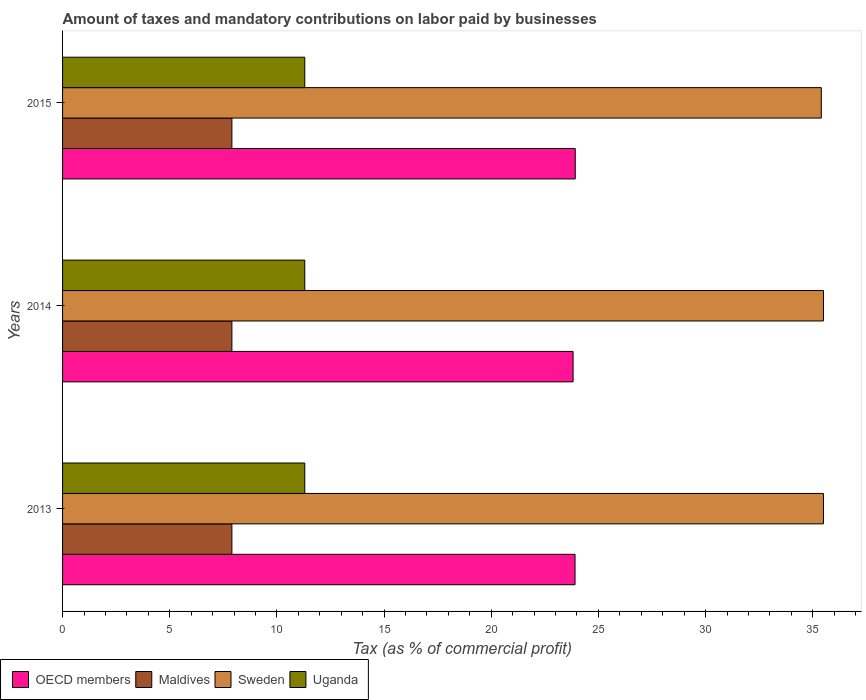How many different coloured bars are there?
Offer a very short reply. 4. How many groups of bars are there?
Keep it short and to the point. 3. How many bars are there on the 3rd tick from the bottom?
Ensure brevity in your answer.  4. What is the label of the 2nd group of bars from the top?
Provide a short and direct response. 2014. In how many cases, is the number of bars for a given year not equal to the number of legend labels?
Give a very brief answer. 0. What is the percentage of taxes paid by businesses in Maldives in 2013?
Keep it short and to the point. 7.9. Across all years, what is the maximum percentage of taxes paid by businesses in Sweden?
Ensure brevity in your answer.  35.5. Across all years, what is the minimum percentage of taxes paid by businesses in OECD members?
Provide a short and direct response. 23.82. In which year was the percentage of taxes paid by businesses in OECD members maximum?
Your answer should be compact. 2015. In which year was the percentage of taxes paid by businesses in OECD members minimum?
Make the answer very short. 2014. What is the total percentage of taxes paid by businesses in Maldives in the graph?
Provide a succinct answer. 23.7. What is the difference between the percentage of taxes paid by businesses in OECD members in 2014 and the percentage of taxes paid by businesses in Sweden in 2015?
Your response must be concise. -11.58. What is the average percentage of taxes paid by businesses in OECD members per year?
Make the answer very short. 23.88. In the year 2014, what is the difference between the percentage of taxes paid by businesses in Uganda and percentage of taxes paid by businesses in OECD members?
Ensure brevity in your answer.  -12.52. What is the ratio of the percentage of taxes paid by businesses in OECD members in 2013 to that in 2014?
Give a very brief answer. 1. Is the difference between the percentage of taxes paid by businesses in Uganda in 2014 and 2015 greater than the difference between the percentage of taxes paid by businesses in OECD members in 2014 and 2015?
Provide a short and direct response. Yes. What is the difference between the highest and the second highest percentage of taxes paid by businesses in Uganda?
Provide a succinct answer. 0. What is the difference between the highest and the lowest percentage of taxes paid by businesses in Sweden?
Keep it short and to the point. 0.1. Is it the case that in every year, the sum of the percentage of taxes paid by businesses in Uganda and percentage of taxes paid by businesses in Maldives is greater than the percentage of taxes paid by businesses in Sweden?
Your response must be concise. No. How many bars are there?
Keep it short and to the point. 12. Are all the bars in the graph horizontal?
Ensure brevity in your answer.  Yes. How many years are there in the graph?
Provide a succinct answer. 3. What is the difference between two consecutive major ticks on the X-axis?
Provide a succinct answer. 5. Are the values on the major ticks of X-axis written in scientific E-notation?
Provide a short and direct response. No. Does the graph contain any zero values?
Provide a short and direct response. No. Does the graph contain grids?
Keep it short and to the point. No. How many legend labels are there?
Provide a short and direct response. 4. What is the title of the graph?
Ensure brevity in your answer.  Amount of taxes and mandatory contributions on labor paid by businesses. Does "Congo (Democratic)" appear as one of the legend labels in the graph?
Keep it short and to the point. No. What is the label or title of the X-axis?
Offer a terse response. Tax (as % of commercial profit). What is the label or title of the Y-axis?
Your response must be concise. Years. What is the Tax (as % of commercial profit) of OECD members in 2013?
Offer a terse response. 23.91. What is the Tax (as % of commercial profit) of Sweden in 2013?
Your response must be concise. 35.5. What is the Tax (as % of commercial profit) in Uganda in 2013?
Provide a short and direct response. 11.3. What is the Tax (as % of commercial profit) in OECD members in 2014?
Ensure brevity in your answer.  23.82. What is the Tax (as % of commercial profit) in Sweden in 2014?
Give a very brief answer. 35.5. What is the Tax (as % of commercial profit) in Uganda in 2014?
Provide a short and direct response. 11.3. What is the Tax (as % of commercial profit) of OECD members in 2015?
Keep it short and to the point. 23.92. What is the Tax (as % of commercial profit) in Sweden in 2015?
Ensure brevity in your answer.  35.4. What is the Tax (as % of commercial profit) in Uganda in 2015?
Offer a very short reply. 11.3. Across all years, what is the maximum Tax (as % of commercial profit) in OECD members?
Give a very brief answer. 23.92. Across all years, what is the maximum Tax (as % of commercial profit) of Maldives?
Provide a short and direct response. 7.9. Across all years, what is the maximum Tax (as % of commercial profit) in Sweden?
Keep it short and to the point. 35.5. Across all years, what is the maximum Tax (as % of commercial profit) in Uganda?
Provide a succinct answer. 11.3. Across all years, what is the minimum Tax (as % of commercial profit) of OECD members?
Make the answer very short. 23.82. Across all years, what is the minimum Tax (as % of commercial profit) of Sweden?
Offer a terse response. 35.4. What is the total Tax (as % of commercial profit) of OECD members in the graph?
Your answer should be very brief. 71.65. What is the total Tax (as % of commercial profit) in Maldives in the graph?
Provide a succinct answer. 23.7. What is the total Tax (as % of commercial profit) of Sweden in the graph?
Provide a short and direct response. 106.4. What is the total Tax (as % of commercial profit) in Uganda in the graph?
Ensure brevity in your answer.  33.9. What is the difference between the Tax (as % of commercial profit) of OECD members in 2013 and that in 2014?
Ensure brevity in your answer.  0.09. What is the difference between the Tax (as % of commercial profit) in Maldives in 2013 and that in 2014?
Offer a very short reply. 0. What is the difference between the Tax (as % of commercial profit) in Sweden in 2013 and that in 2014?
Offer a terse response. 0. What is the difference between the Tax (as % of commercial profit) of OECD members in 2013 and that in 2015?
Offer a very short reply. -0.01. What is the difference between the Tax (as % of commercial profit) of Uganda in 2013 and that in 2015?
Make the answer very short. 0. What is the difference between the Tax (as % of commercial profit) in Maldives in 2014 and that in 2015?
Offer a terse response. 0. What is the difference between the Tax (as % of commercial profit) in Sweden in 2014 and that in 2015?
Provide a succinct answer. 0.1. What is the difference between the Tax (as % of commercial profit) of Uganda in 2014 and that in 2015?
Offer a terse response. 0. What is the difference between the Tax (as % of commercial profit) in OECD members in 2013 and the Tax (as % of commercial profit) in Maldives in 2014?
Provide a succinct answer. 16.01. What is the difference between the Tax (as % of commercial profit) in OECD members in 2013 and the Tax (as % of commercial profit) in Sweden in 2014?
Your answer should be very brief. -11.59. What is the difference between the Tax (as % of commercial profit) of OECD members in 2013 and the Tax (as % of commercial profit) of Uganda in 2014?
Give a very brief answer. 12.61. What is the difference between the Tax (as % of commercial profit) in Maldives in 2013 and the Tax (as % of commercial profit) in Sweden in 2014?
Offer a very short reply. -27.6. What is the difference between the Tax (as % of commercial profit) of Sweden in 2013 and the Tax (as % of commercial profit) of Uganda in 2014?
Provide a short and direct response. 24.2. What is the difference between the Tax (as % of commercial profit) in OECD members in 2013 and the Tax (as % of commercial profit) in Maldives in 2015?
Keep it short and to the point. 16.01. What is the difference between the Tax (as % of commercial profit) in OECD members in 2013 and the Tax (as % of commercial profit) in Sweden in 2015?
Your answer should be very brief. -11.49. What is the difference between the Tax (as % of commercial profit) of OECD members in 2013 and the Tax (as % of commercial profit) of Uganda in 2015?
Your answer should be compact. 12.61. What is the difference between the Tax (as % of commercial profit) in Maldives in 2013 and the Tax (as % of commercial profit) in Sweden in 2015?
Ensure brevity in your answer.  -27.5. What is the difference between the Tax (as % of commercial profit) in Maldives in 2013 and the Tax (as % of commercial profit) in Uganda in 2015?
Give a very brief answer. -3.4. What is the difference between the Tax (as % of commercial profit) of Sweden in 2013 and the Tax (as % of commercial profit) of Uganda in 2015?
Give a very brief answer. 24.2. What is the difference between the Tax (as % of commercial profit) in OECD members in 2014 and the Tax (as % of commercial profit) in Maldives in 2015?
Offer a very short reply. 15.92. What is the difference between the Tax (as % of commercial profit) of OECD members in 2014 and the Tax (as % of commercial profit) of Sweden in 2015?
Make the answer very short. -11.58. What is the difference between the Tax (as % of commercial profit) in OECD members in 2014 and the Tax (as % of commercial profit) in Uganda in 2015?
Offer a terse response. 12.52. What is the difference between the Tax (as % of commercial profit) in Maldives in 2014 and the Tax (as % of commercial profit) in Sweden in 2015?
Your response must be concise. -27.5. What is the difference between the Tax (as % of commercial profit) in Maldives in 2014 and the Tax (as % of commercial profit) in Uganda in 2015?
Offer a very short reply. -3.4. What is the difference between the Tax (as % of commercial profit) in Sweden in 2014 and the Tax (as % of commercial profit) in Uganda in 2015?
Your answer should be very brief. 24.2. What is the average Tax (as % of commercial profit) in OECD members per year?
Ensure brevity in your answer.  23.88. What is the average Tax (as % of commercial profit) in Sweden per year?
Your answer should be compact. 35.47. In the year 2013, what is the difference between the Tax (as % of commercial profit) of OECD members and Tax (as % of commercial profit) of Maldives?
Your response must be concise. 16.01. In the year 2013, what is the difference between the Tax (as % of commercial profit) of OECD members and Tax (as % of commercial profit) of Sweden?
Your answer should be compact. -11.59. In the year 2013, what is the difference between the Tax (as % of commercial profit) of OECD members and Tax (as % of commercial profit) of Uganda?
Give a very brief answer. 12.61. In the year 2013, what is the difference between the Tax (as % of commercial profit) of Maldives and Tax (as % of commercial profit) of Sweden?
Provide a succinct answer. -27.6. In the year 2013, what is the difference between the Tax (as % of commercial profit) in Maldives and Tax (as % of commercial profit) in Uganda?
Make the answer very short. -3.4. In the year 2013, what is the difference between the Tax (as % of commercial profit) in Sweden and Tax (as % of commercial profit) in Uganda?
Keep it short and to the point. 24.2. In the year 2014, what is the difference between the Tax (as % of commercial profit) in OECD members and Tax (as % of commercial profit) in Maldives?
Give a very brief answer. 15.92. In the year 2014, what is the difference between the Tax (as % of commercial profit) in OECD members and Tax (as % of commercial profit) in Sweden?
Keep it short and to the point. -11.68. In the year 2014, what is the difference between the Tax (as % of commercial profit) of OECD members and Tax (as % of commercial profit) of Uganda?
Make the answer very short. 12.52. In the year 2014, what is the difference between the Tax (as % of commercial profit) in Maldives and Tax (as % of commercial profit) in Sweden?
Ensure brevity in your answer.  -27.6. In the year 2014, what is the difference between the Tax (as % of commercial profit) of Sweden and Tax (as % of commercial profit) of Uganda?
Ensure brevity in your answer.  24.2. In the year 2015, what is the difference between the Tax (as % of commercial profit) in OECD members and Tax (as % of commercial profit) in Maldives?
Your answer should be compact. 16.02. In the year 2015, what is the difference between the Tax (as % of commercial profit) in OECD members and Tax (as % of commercial profit) in Sweden?
Your answer should be very brief. -11.48. In the year 2015, what is the difference between the Tax (as % of commercial profit) of OECD members and Tax (as % of commercial profit) of Uganda?
Provide a succinct answer. 12.62. In the year 2015, what is the difference between the Tax (as % of commercial profit) of Maldives and Tax (as % of commercial profit) of Sweden?
Offer a very short reply. -27.5. In the year 2015, what is the difference between the Tax (as % of commercial profit) in Maldives and Tax (as % of commercial profit) in Uganda?
Ensure brevity in your answer.  -3.4. In the year 2015, what is the difference between the Tax (as % of commercial profit) of Sweden and Tax (as % of commercial profit) of Uganda?
Make the answer very short. 24.1. What is the ratio of the Tax (as % of commercial profit) in Maldives in 2013 to that in 2014?
Make the answer very short. 1. What is the ratio of the Tax (as % of commercial profit) of Sweden in 2013 to that in 2014?
Keep it short and to the point. 1. What is the ratio of the Tax (as % of commercial profit) in Uganda in 2013 to that in 2014?
Ensure brevity in your answer.  1. What is the ratio of the Tax (as % of commercial profit) of OECD members in 2013 to that in 2015?
Make the answer very short. 1. What is the ratio of the Tax (as % of commercial profit) in Maldives in 2013 to that in 2015?
Your answer should be compact. 1. What is the ratio of the Tax (as % of commercial profit) in Uganda in 2014 to that in 2015?
Your answer should be compact. 1. What is the difference between the highest and the second highest Tax (as % of commercial profit) of OECD members?
Provide a succinct answer. 0.01. What is the difference between the highest and the second highest Tax (as % of commercial profit) in Maldives?
Your response must be concise. 0. What is the difference between the highest and the second highest Tax (as % of commercial profit) in Uganda?
Your answer should be compact. 0. What is the difference between the highest and the lowest Tax (as % of commercial profit) of Maldives?
Provide a succinct answer. 0. 